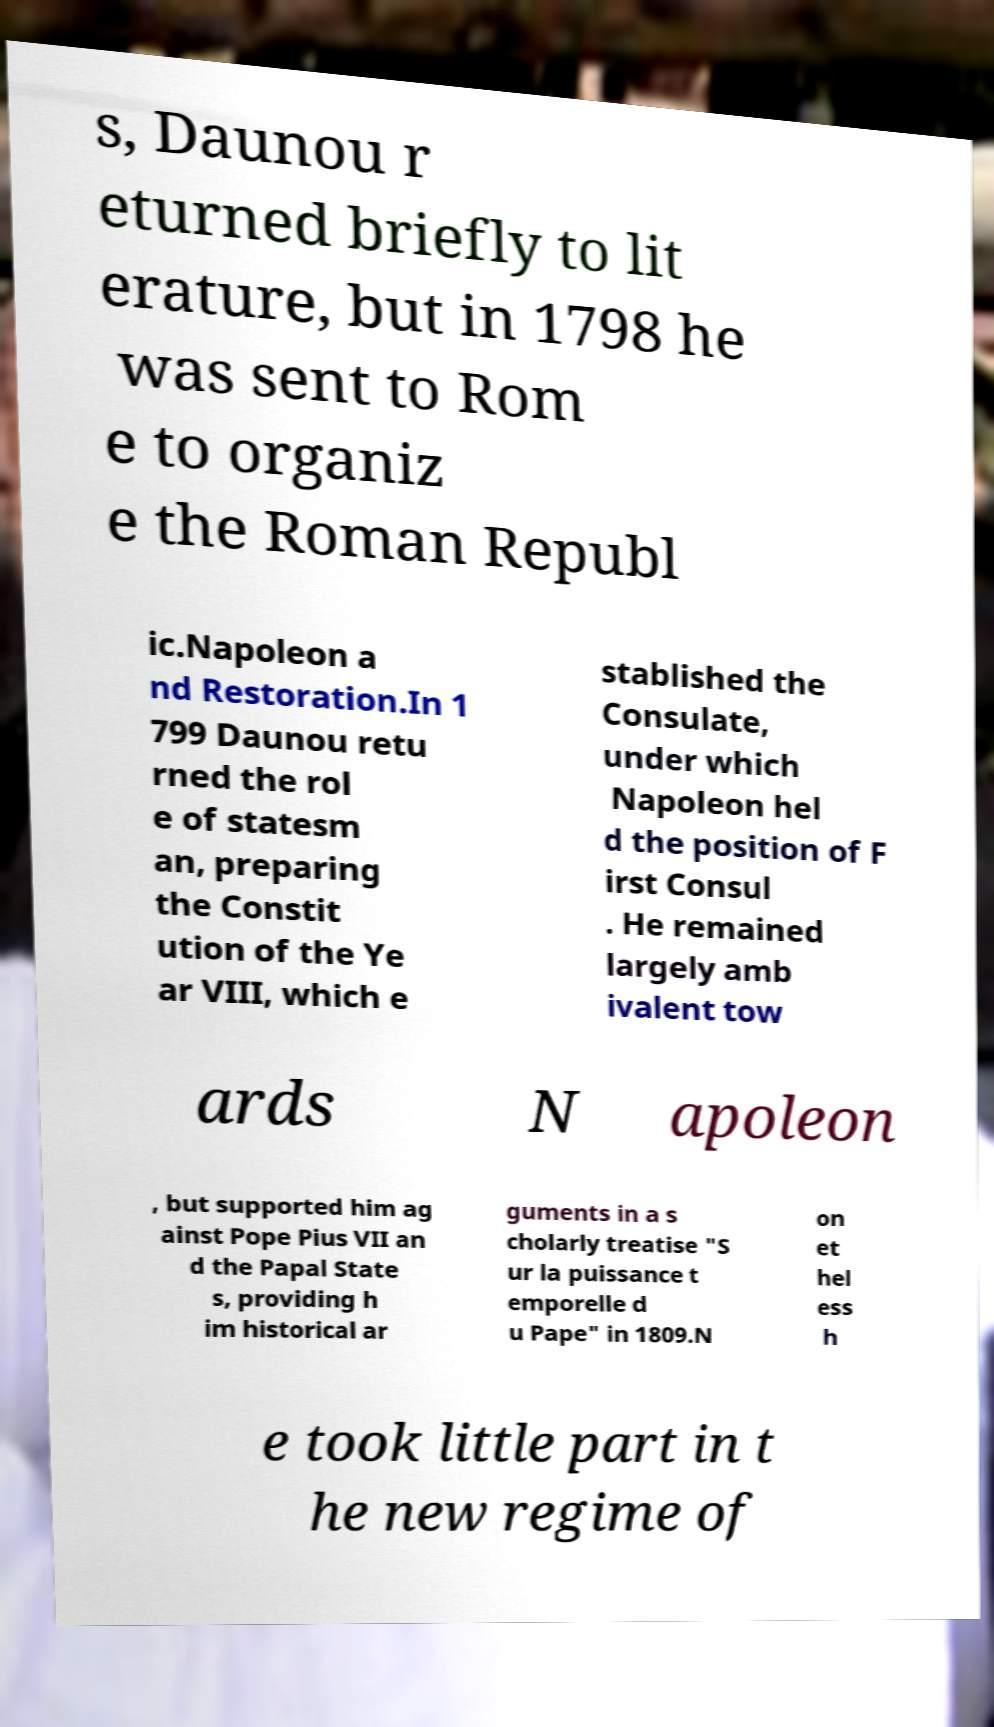There's text embedded in this image that I need extracted. Can you transcribe it verbatim? s, Daunou r eturned briefly to lit erature, but in 1798 he was sent to Rom e to organiz e the Roman Republ ic.Napoleon a nd Restoration.In 1 799 Daunou retu rned the rol e of statesm an, preparing the Constit ution of the Ye ar VIII, which e stablished the Consulate, under which Napoleon hel d the position of F irst Consul . He remained largely amb ivalent tow ards N apoleon , but supported him ag ainst Pope Pius VII an d the Papal State s, providing h im historical ar guments in a s cholarly treatise "S ur la puissance t emporelle d u Pape" in 1809.N on et hel ess h e took little part in t he new regime of 